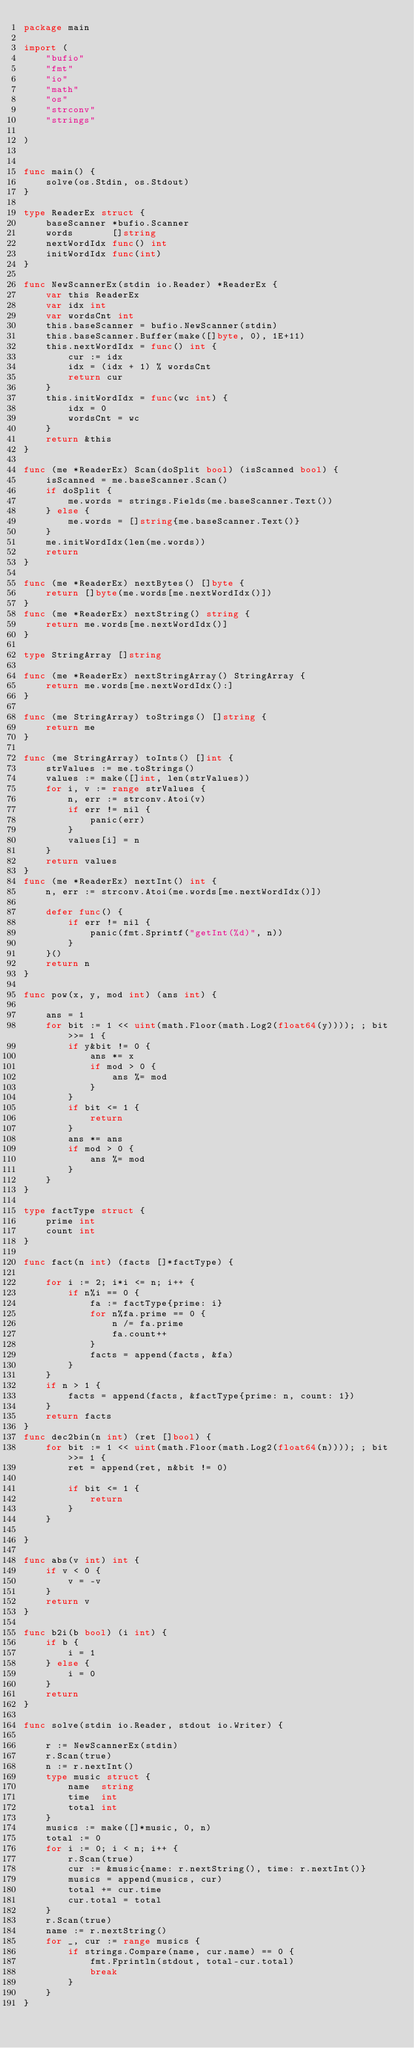Convert code to text. <code><loc_0><loc_0><loc_500><loc_500><_Go_>package main

import (
	"bufio"
	"fmt"
	"io"
	"math"
	"os"
	"strconv"
	"strings"

)


func main() {
	solve(os.Stdin, os.Stdout)
}

type ReaderEx struct {
	baseScanner *bufio.Scanner
	words       []string
	nextWordIdx func() int
	initWordIdx func(int)
}

func NewScannerEx(stdin io.Reader) *ReaderEx {
	var this ReaderEx
	var idx int
	var wordsCnt int
	this.baseScanner = bufio.NewScanner(stdin)
	this.baseScanner.Buffer(make([]byte, 0), 1E+11)
	this.nextWordIdx = func() int {
		cur := idx
		idx = (idx + 1) % wordsCnt
		return cur
	}
	this.initWordIdx = func(wc int) {
		idx = 0
		wordsCnt = wc
	}
	return &this
}

func (me *ReaderEx) Scan(doSplit bool) (isScanned bool) {
	isScanned = me.baseScanner.Scan()
	if doSplit {
		me.words = strings.Fields(me.baseScanner.Text())
	} else {
		me.words = []string{me.baseScanner.Text()}
	}
	me.initWordIdx(len(me.words))
	return
}

func (me *ReaderEx) nextBytes() []byte {
	return []byte(me.words[me.nextWordIdx()])
}
func (me *ReaderEx) nextString() string {
	return me.words[me.nextWordIdx()]
}

type StringArray []string

func (me *ReaderEx) nextStringArray() StringArray {
	return me.words[me.nextWordIdx():]
}

func (me StringArray) toStrings() []string {
	return me
}

func (me StringArray) toInts() []int {
	strValues := me.toStrings()
	values := make([]int, len(strValues))
	for i, v := range strValues {
		n, err := strconv.Atoi(v)
		if err != nil {
			panic(err)
		}
		values[i] = n
	}
	return values
}
func (me *ReaderEx) nextInt() int {
	n, err := strconv.Atoi(me.words[me.nextWordIdx()])

	defer func() {
		if err != nil {
			panic(fmt.Sprintf("getInt(%d)", n))
		}
	}()
	return n
}

func pow(x, y, mod int) (ans int) {

	ans = 1
	for bit := 1 << uint(math.Floor(math.Log2(float64(y)))); ; bit >>= 1 {
		if y&bit != 0 {
			ans *= x
			if mod > 0 {
				ans %= mod
			}
		}
		if bit <= 1 {
			return
		}
		ans *= ans
		if mod > 0 {
			ans %= mod
		}
	}
}

type factType struct {
	prime int
	count int
}

func fact(n int) (facts []*factType) {

	for i := 2; i*i <= n; i++ {
		if n%i == 0 {
			fa := factType{prime: i}
			for n%fa.prime == 0 {
				n /= fa.prime
				fa.count++
			}
			facts = append(facts, &fa)
		}
	}
	if n > 1 {
		facts = append(facts, &factType{prime: n, count: 1})
	}
	return facts
}
func dec2bin(n int) (ret []bool) {
	for bit := 1 << uint(math.Floor(math.Log2(float64(n)))); ; bit >>= 1 {
		ret = append(ret, n&bit != 0)

		if bit <= 1 {
			return
		}
	}

}

func abs(v int) int {
	if v < 0 {
		v = -v
	}
	return v
}

func b2i(b bool) (i int) {
	if b {
		i = 1
	} else {
		i = 0
	}
	return
}

func solve(stdin io.Reader, stdout io.Writer) {

	r := NewScannerEx(stdin)
	r.Scan(true)
	n := r.nextInt()
	type music struct {
		name  string
		time  int
		total int
	}
	musics := make([]*music, 0, n)
	total := 0
	for i := 0; i < n; i++ {
		r.Scan(true)
		cur := &music{name: r.nextString(), time: r.nextInt()}
		musics = append(musics, cur)
		total += cur.time
		cur.total = total
	}
	r.Scan(true)
	name := r.nextString()
	for _, cur := range musics {
		if strings.Compare(name, cur.name) == 0 {
			fmt.Fprintln(stdout, total-cur.total)
			break
		}
	}
}
</code> 